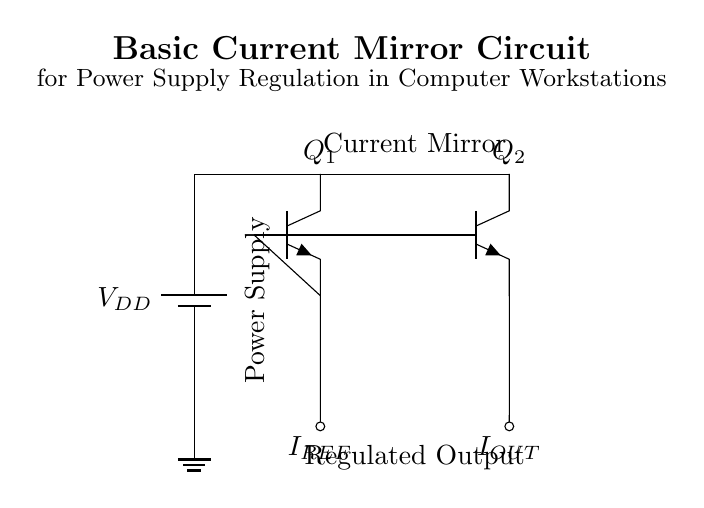What is the configuration of the transistors in the circuit? The transistors Q1 and Q2 are configured as a current mirror. This means that the base of Q2 is connected to the base of Q1, allowing the same reference current to control the output current.
Answer: Current mirror What is the purpose of the power supply in this circuit? The power supply provides the necessary voltage (V_{DD}) to the circuit, allowing the transistors Q1 and Q2 to operate and regulate the output current (I_{OUT}).
Answer: Supply voltage What is the relationship between I_{REF} and I_{OUT} in a current mirror? In an ideal current mirror, I_{OUT} is designed to equal I_{REF}, meaning that the output current follows the reference current, assuming the transistors are matched and the circuit operates under ideal conditions.
Answer: I_{OUT} equals I_{REF} How many terminals do the transistors Q1 and Q2 have? Each transistor has three terminals: the collector, base, and emitter (C, B, E).
Answer: Three What type of current is I_{OUT} in this circuit? I_{OUT} is a regulated output current, which ideally mirrors I_{REF} as set by the circuit design, providing stable current for load applications.
Answer: Regulated current What is the role of the ground in this circuit? Ground acts as the reference point in the circuit, establishing the zero-voltage level against which other voltages are measured and completing the circuit for current flow.
Answer: Reference point What is indicated by the label "Current Mirror" in the circuit? The label indicates that the section of the circuit where Q1 and Q2 are located functions to replicate the input current (I_{REF}) at the output (I_{OUT}), thereby regulating the current supply for the load.
Answer: Current replication function 